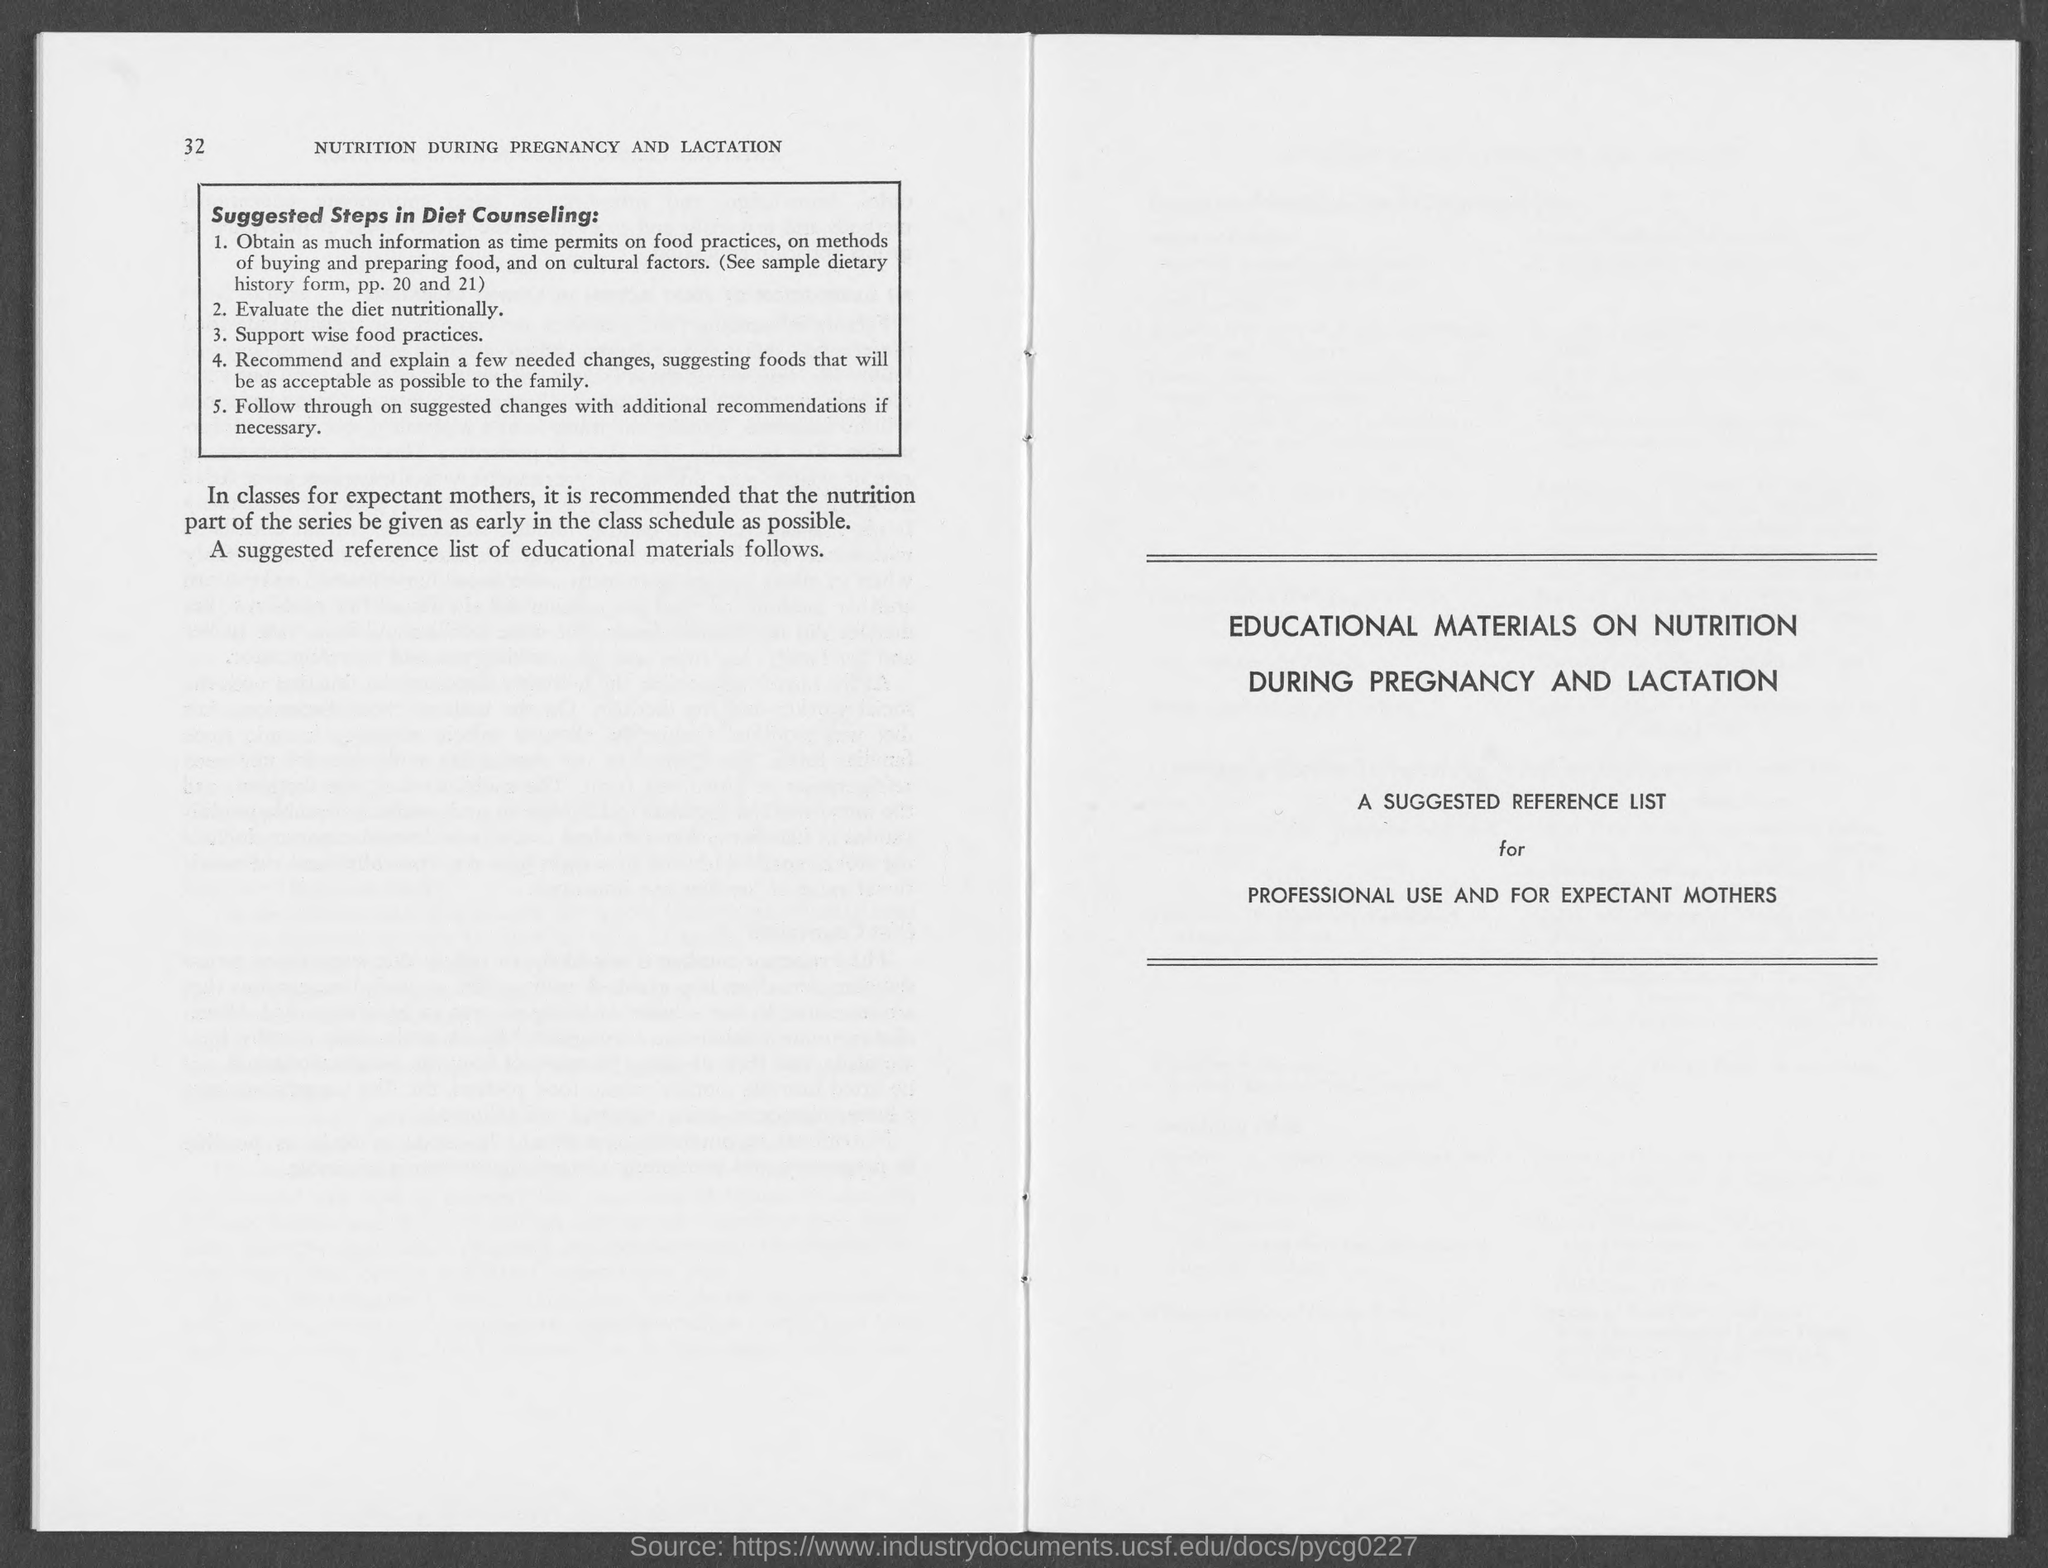What is the number at top-left corner of the page ?
Give a very brief answer. 32. 